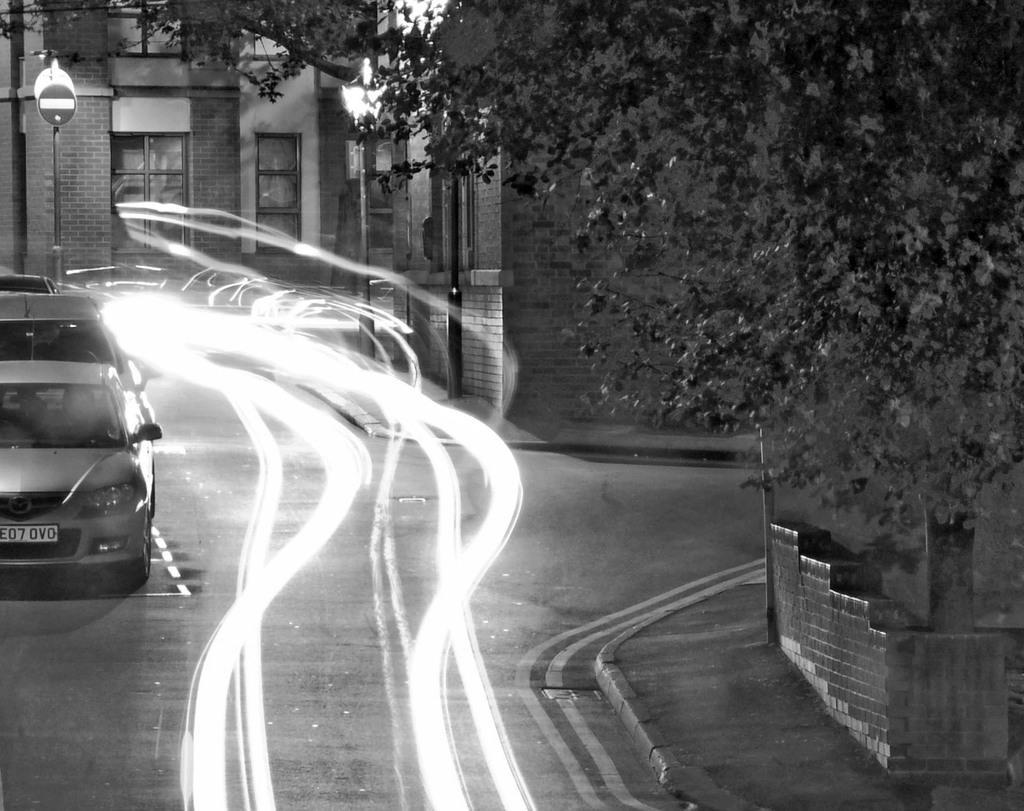In one or two sentences, can you explain what this image depicts? In this image there is a road on which there are cars on the left side and there is a reflection of lights in the middle. On the right side there is a tree. In the background there is a building with the windows. On the left side there is a signal board. 